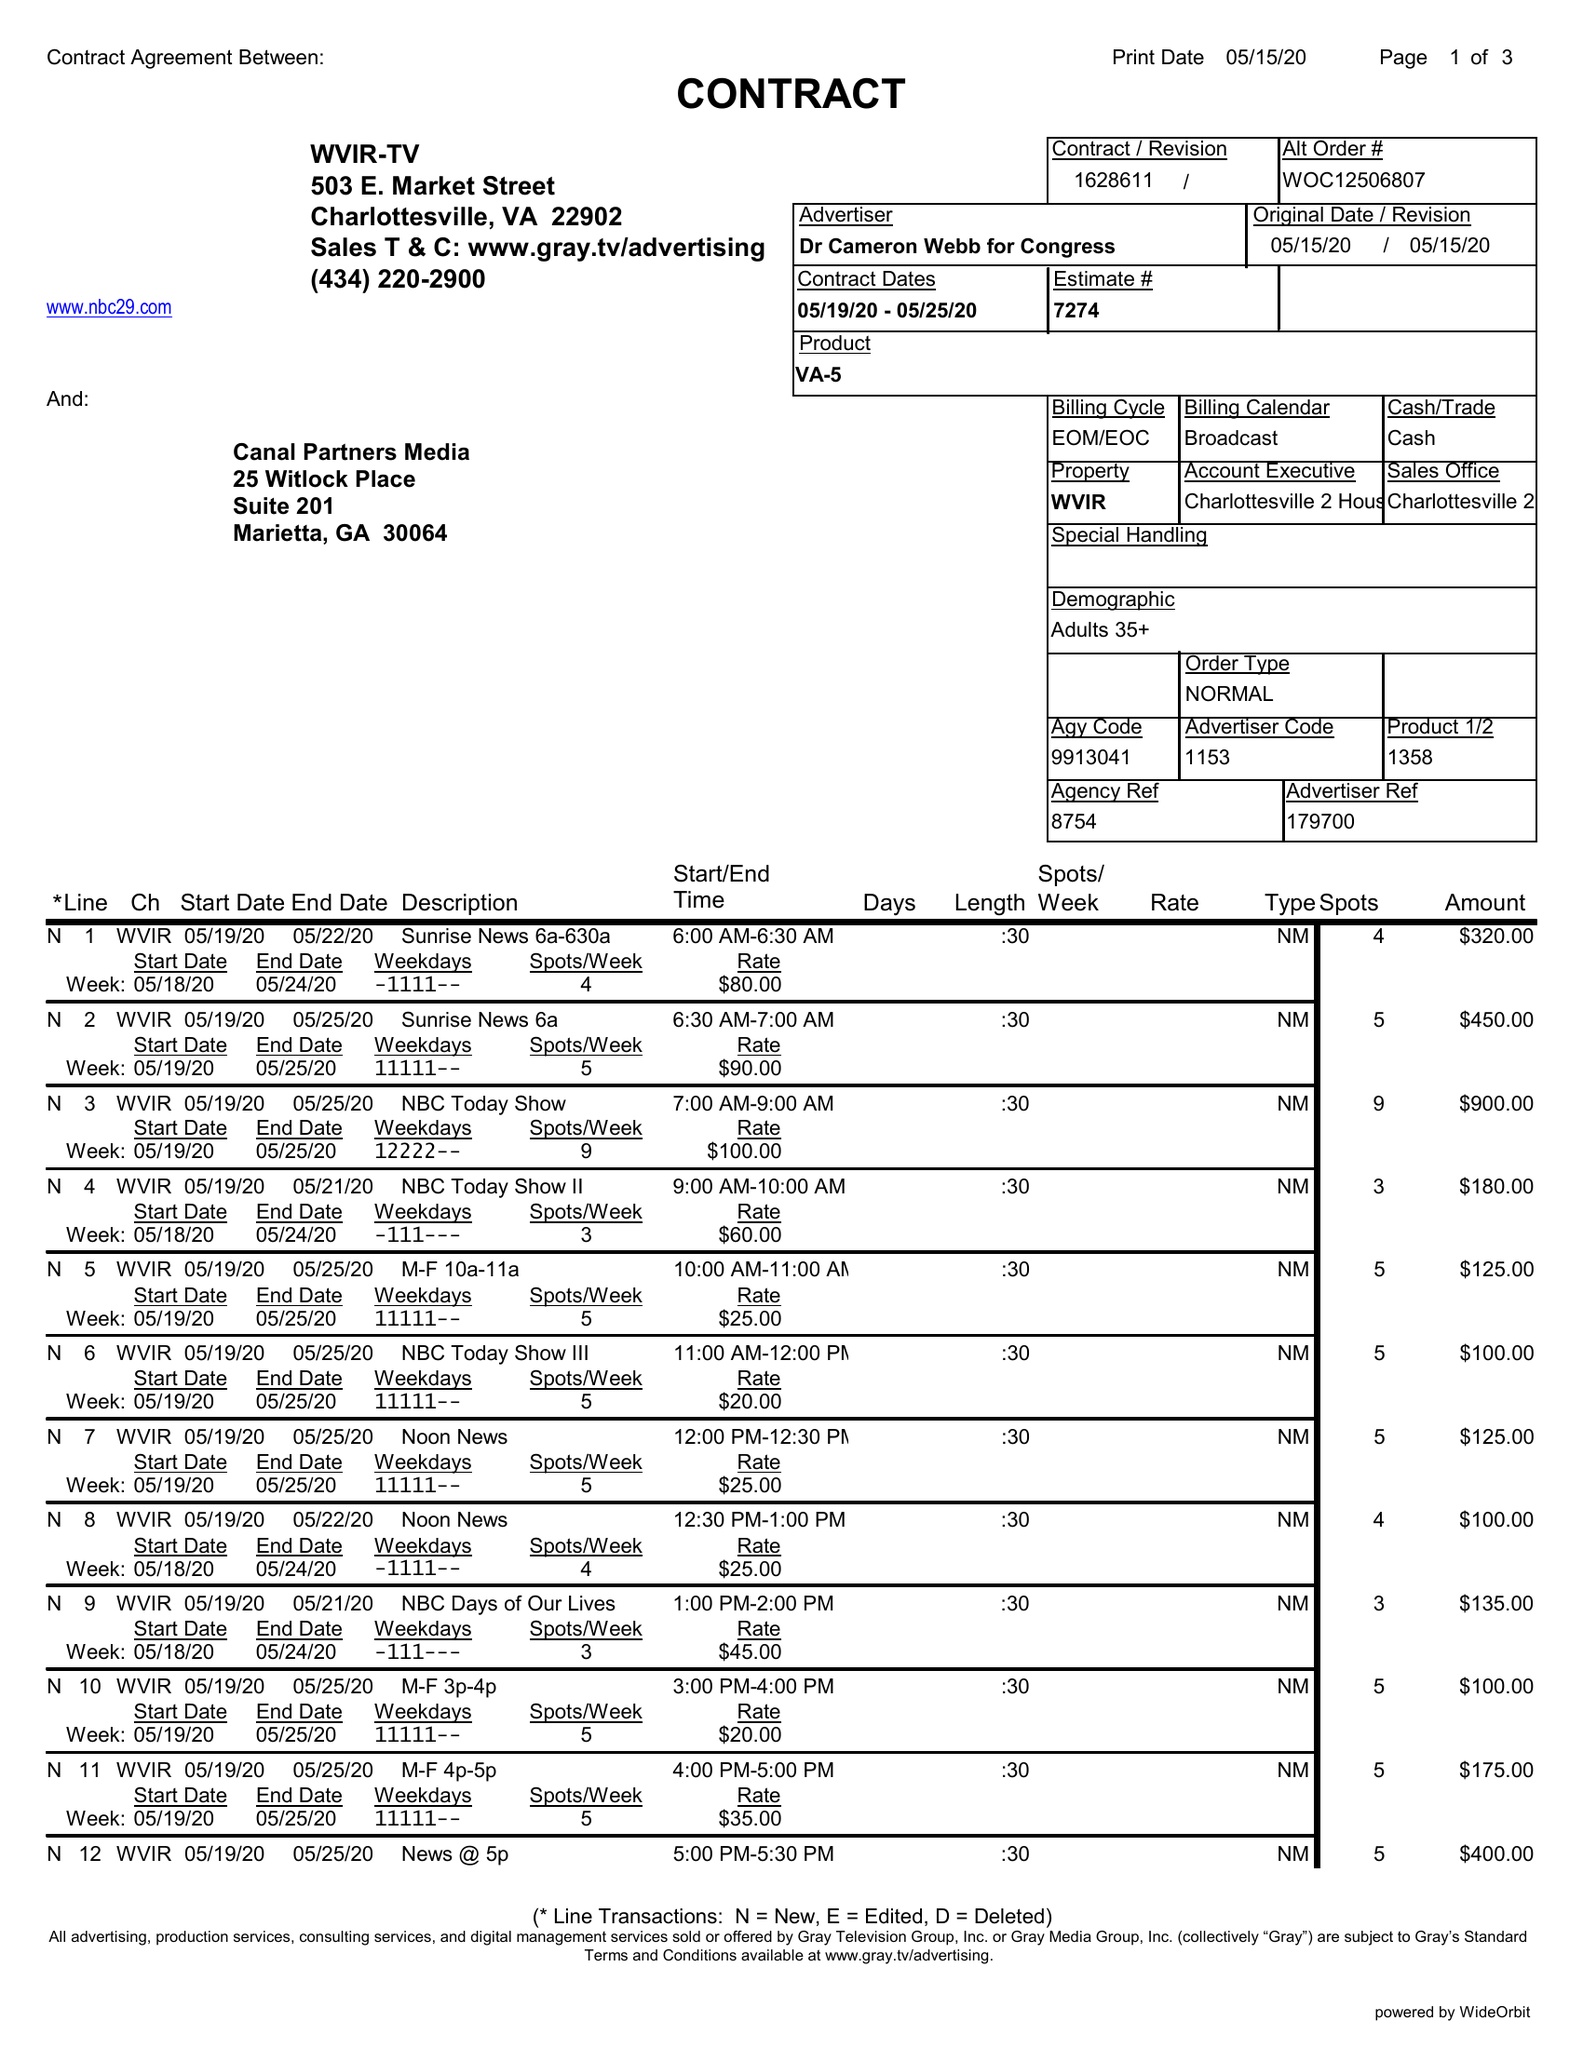What is the value for the flight_from?
Answer the question using a single word or phrase. 05/19/20 